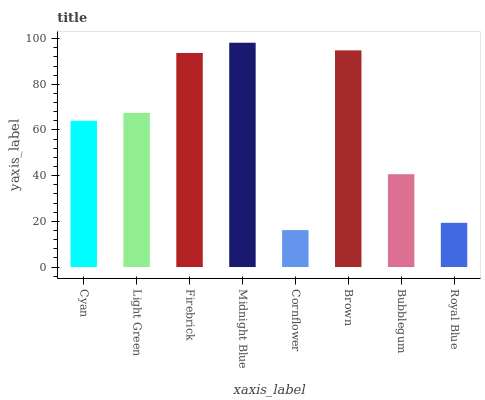Is Cornflower the minimum?
Answer yes or no. Yes. Is Midnight Blue the maximum?
Answer yes or no. Yes. Is Light Green the minimum?
Answer yes or no. No. Is Light Green the maximum?
Answer yes or no. No. Is Light Green greater than Cyan?
Answer yes or no. Yes. Is Cyan less than Light Green?
Answer yes or no. Yes. Is Cyan greater than Light Green?
Answer yes or no. No. Is Light Green less than Cyan?
Answer yes or no. No. Is Light Green the high median?
Answer yes or no. Yes. Is Cyan the low median?
Answer yes or no. Yes. Is Midnight Blue the high median?
Answer yes or no. No. Is Bubblegum the low median?
Answer yes or no. No. 